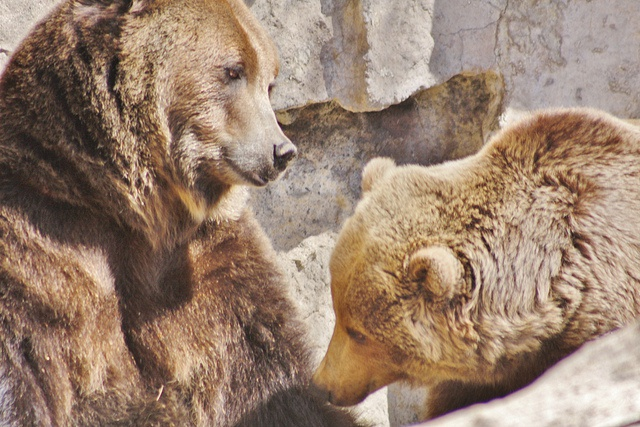Describe the objects in this image and their specific colors. I can see bear in darkgray, gray, maroon, brown, and tan tones and bear in darkgray, gray, and tan tones in this image. 